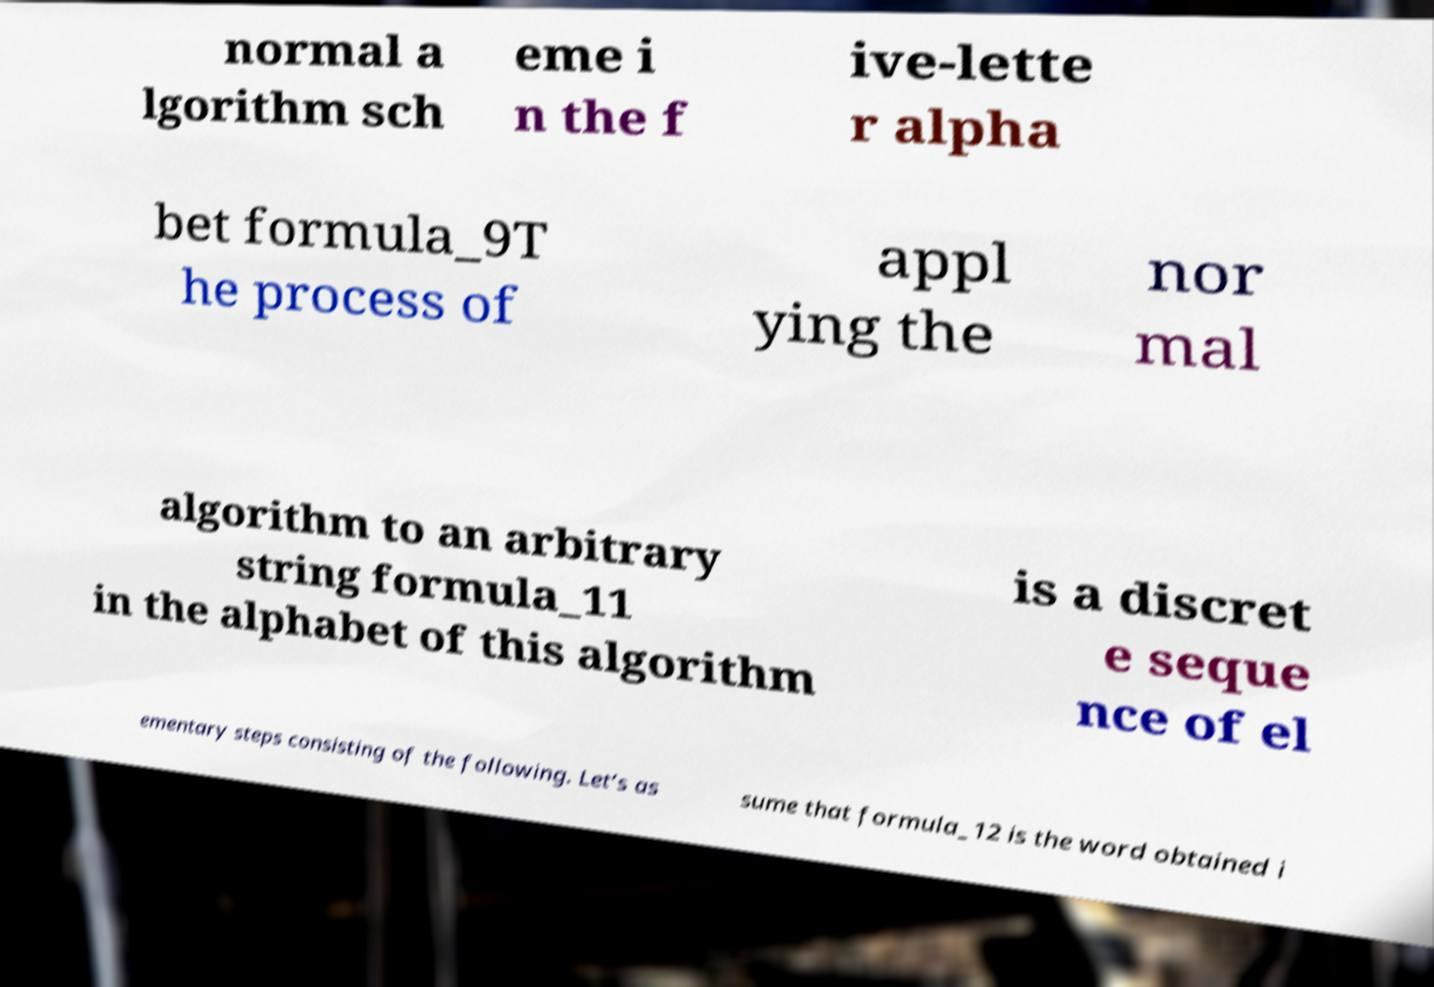Can you accurately transcribe the text from the provided image for me? normal a lgorithm sch eme i n the f ive-lette r alpha bet formula_9T he process of appl ying the nor mal algorithm to an arbitrary string formula_11 in the alphabet of this algorithm is a discret e seque nce of el ementary steps consisting of the following. Let’s as sume that formula_12 is the word obtained i 